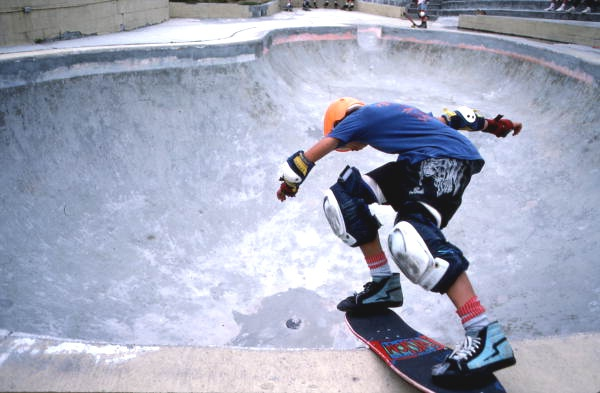Describe the objects in this image and their specific colors. I can see people in gray, black, navy, lavender, and blue tones, skateboard in gray, black, navy, and purple tones, people in gray and black tones, people in gray, darkgray, lavender, and black tones, and people in gray and black tones in this image. 